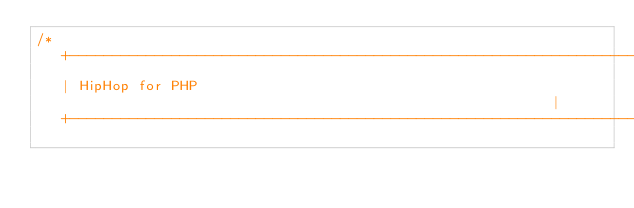<code> <loc_0><loc_0><loc_500><loc_500><_C_>/*
   +----------------------------------------------------------------------+
   | HipHop for PHP                                                       |
   +----------------------------------------------------------------------+</code> 